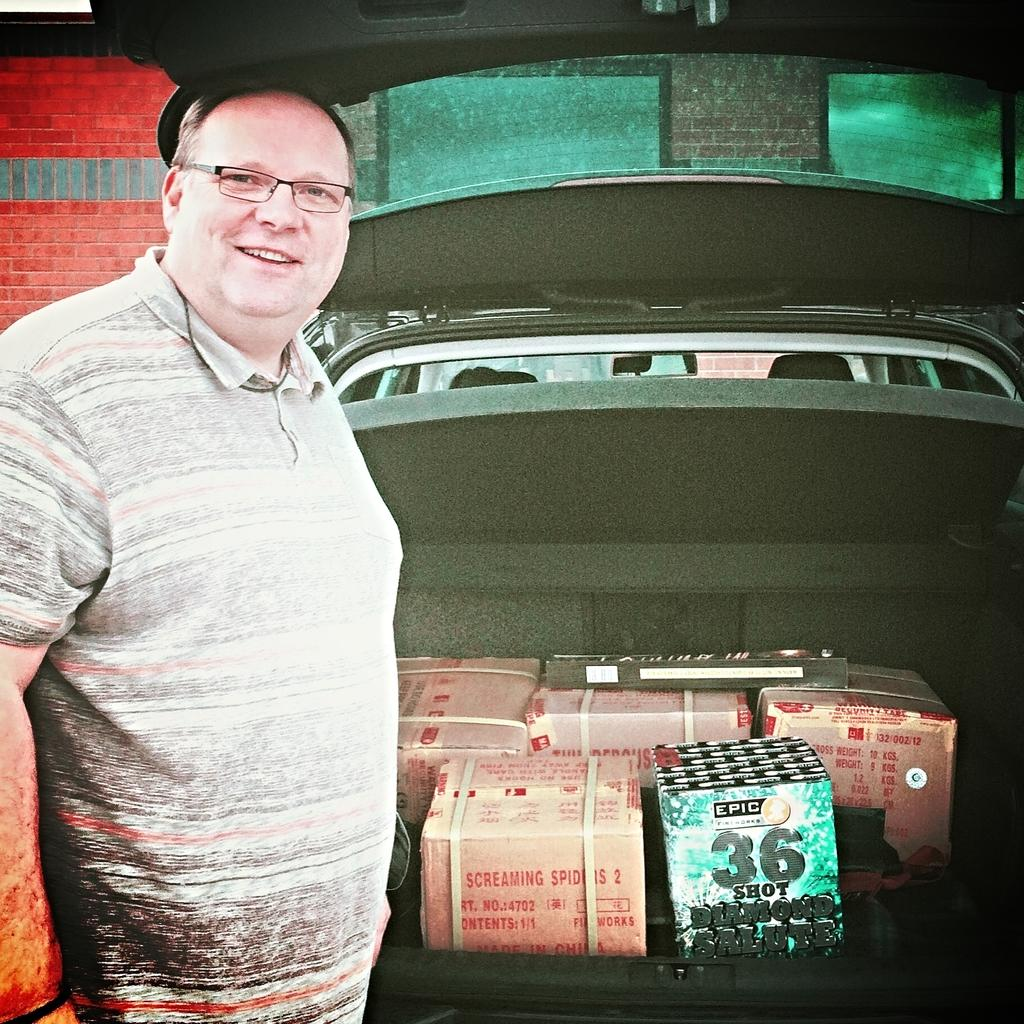Who is present in the image? There is a man in the image. What is the man wearing? The man is wearing spectacles. What is the man doing in the image? The man is standing and smiling. What can be seen near the man in the image? There are boxes in a vehicle beside the man. What is visible in the background of the image? There is a wall visible in the background of the image. How many ducks are sitting on the fork in the image? There are no ducks or forks present in the image. What type of bridge can be seen in the background of the image? There is no bridge visible in the background of the image; only a wall is present. 